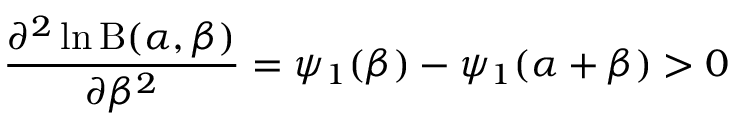Convert formula to latex. <formula><loc_0><loc_0><loc_500><loc_500>{ \frac { \partial ^ { 2 } \ln B ( \alpha , \beta ) } { \partial \beta ^ { 2 } } } = \psi _ { 1 } ( \beta ) - \psi _ { 1 } ( \alpha + \beta ) > 0</formula> 